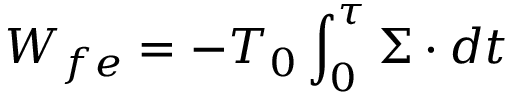Convert formula to latex. <formula><loc_0><loc_0><loc_500><loc_500>W _ { f e } = - T _ { 0 } \int _ { 0 } ^ { \tau } \Sigma \cdot d t</formula> 